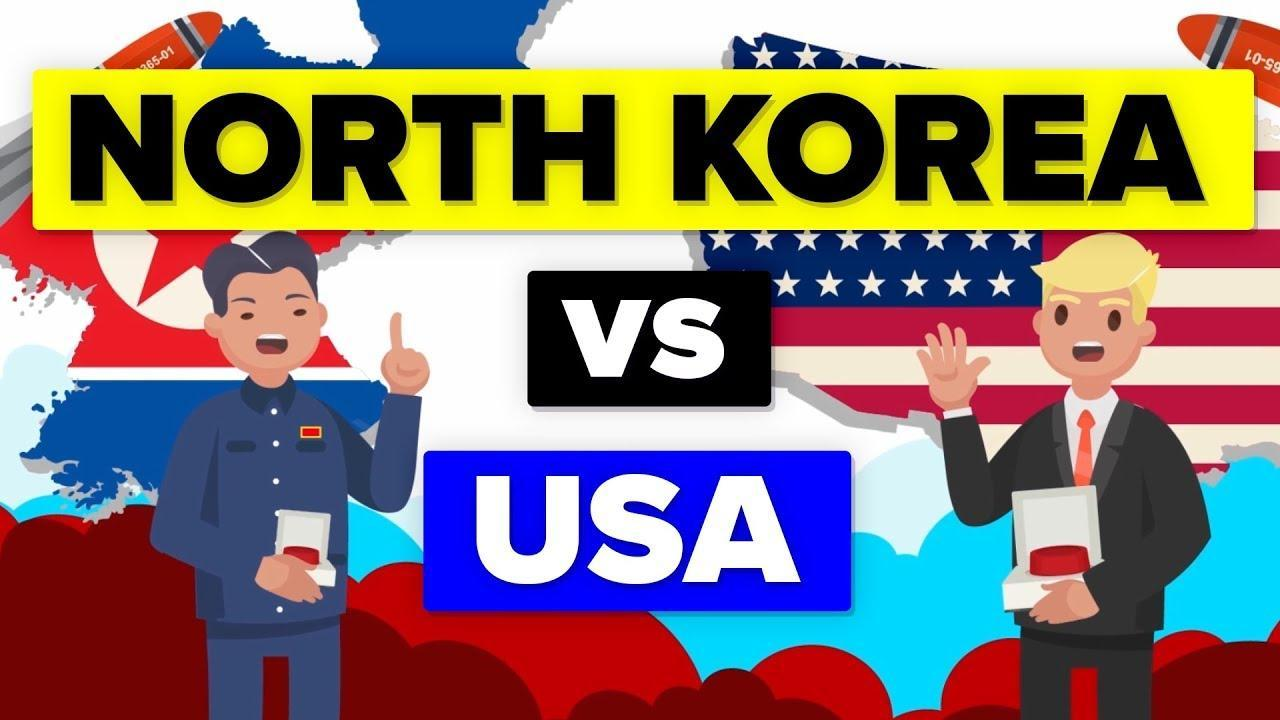what is the colour of the tie, red or white
Answer the question with a short phrase. red what is the colour of the star in USA flag, blue or white white what is the colour of the star in North Korea flag, red or white red 